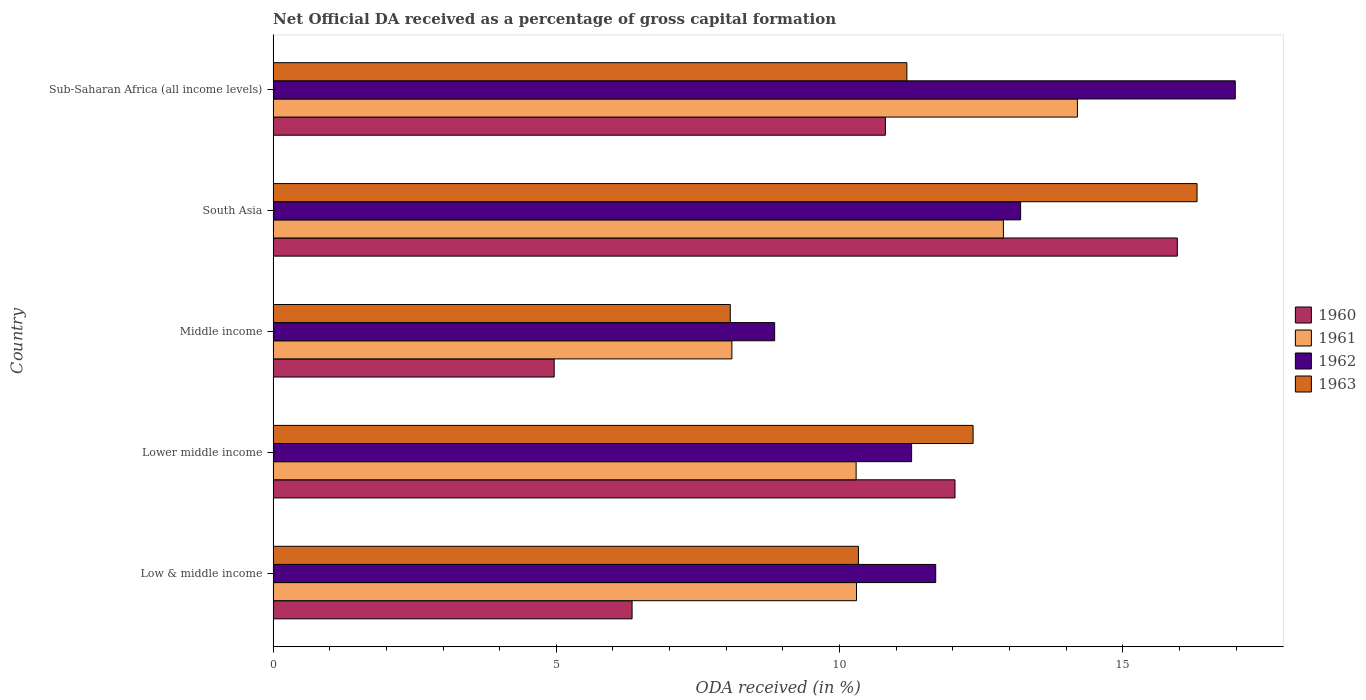How many different coloured bars are there?
Provide a short and direct response. 4. Are the number of bars per tick equal to the number of legend labels?
Give a very brief answer. Yes. How many bars are there on the 2nd tick from the top?
Make the answer very short. 4. What is the label of the 1st group of bars from the top?
Give a very brief answer. Sub-Saharan Africa (all income levels). What is the net ODA received in 1960 in Middle income?
Your answer should be very brief. 4.96. Across all countries, what is the maximum net ODA received in 1962?
Provide a succinct answer. 16.99. Across all countries, what is the minimum net ODA received in 1962?
Keep it short and to the point. 8.85. In which country was the net ODA received in 1963 maximum?
Give a very brief answer. South Asia. What is the total net ODA received in 1963 in the graph?
Provide a succinct answer. 58.26. What is the difference between the net ODA received in 1963 in Lower middle income and that in South Asia?
Offer a very short reply. -3.95. What is the difference between the net ODA received in 1961 in Middle income and the net ODA received in 1960 in Low & middle income?
Provide a short and direct response. 1.76. What is the average net ODA received in 1960 per country?
Offer a terse response. 10.02. What is the difference between the net ODA received in 1962 and net ODA received in 1960 in Low & middle income?
Provide a succinct answer. 5.36. In how many countries, is the net ODA received in 1961 greater than 6 %?
Your answer should be very brief. 5. What is the ratio of the net ODA received in 1962 in Low & middle income to that in Sub-Saharan Africa (all income levels)?
Provide a short and direct response. 0.69. What is the difference between the highest and the second highest net ODA received in 1960?
Your answer should be very brief. 3.93. What is the difference between the highest and the lowest net ODA received in 1960?
Keep it short and to the point. 11. In how many countries, is the net ODA received in 1962 greater than the average net ODA received in 1962 taken over all countries?
Your response must be concise. 2. Is the sum of the net ODA received in 1960 in Low & middle income and South Asia greater than the maximum net ODA received in 1962 across all countries?
Your response must be concise. Yes. Is it the case that in every country, the sum of the net ODA received in 1961 and net ODA received in 1963 is greater than the sum of net ODA received in 1960 and net ODA received in 1962?
Give a very brief answer. No. What does the 3rd bar from the top in Lower middle income represents?
Your answer should be compact. 1961. What does the 4th bar from the bottom in Lower middle income represents?
Offer a very short reply. 1963. How many bars are there?
Ensure brevity in your answer.  20. How many countries are there in the graph?
Offer a terse response. 5. Does the graph contain grids?
Your answer should be compact. No. How many legend labels are there?
Your answer should be very brief. 4. How are the legend labels stacked?
Your answer should be very brief. Vertical. What is the title of the graph?
Provide a short and direct response. Net Official DA received as a percentage of gross capital formation. Does "1975" appear as one of the legend labels in the graph?
Give a very brief answer. No. What is the label or title of the X-axis?
Your answer should be compact. ODA received (in %). What is the label or title of the Y-axis?
Your response must be concise. Country. What is the ODA received (in %) in 1960 in Low & middle income?
Provide a short and direct response. 6.34. What is the ODA received (in %) of 1961 in Low & middle income?
Make the answer very short. 10.3. What is the ODA received (in %) in 1962 in Low & middle income?
Keep it short and to the point. 11.7. What is the ODA received (in %) of 1963 in Low & middle income?
Make the answer very short. 10.33. What is the ODA received (in %) of 1960 in Lower middle income?
Your answer should be compact. 12.04. What is the ODA received (in %) in 1961 in Lower middle income?
Give a very brief answer. 10.29. What is the ODA received (in %) of 1962 in Lower middle income?
Keep it short and to the point. 11.27. What is the ODA received (in %) of 1963 in Lower middle income?
Your answer should be compact. 12.36. What is the ODA received (in %) in 1960 in Middle income?
Provide a succinct answer. 4.96. What is the ODA received (in %) in 1961 in Middle income?
Your response must be concise. 8.1. What is the ODA received (in %) in 1962 in Middle income?
Your answer should be very brief. 8.85. What is the ODA received (in %) in 1963 in Middle income?
Offer a very short reply. 8.07. What is the ODA received (in %) of 1960 in South Asia?
Make the answer very short. 15.96. What is the ODA received (in %) in 1961 in South Asia?
Provide a succinct answer. 12.89. What is the ODA received (in %) of 1962 in South Asia?
Provide a succinct answer. 13.2. What is the ODA received (in %) of 1963 in South Asia?
Offer a terse response. 16.31. What is the ODA received (in %) in 1960 in Sub-Saharan Africa (all income levels)?
Keep it short and to the point. 10.81. What is the ODA received (in %) in 1961 in Sub-Saharan Africa (all income levels)?
Give a very brief answer. 14.2. What is the ODA received (in %) of 1962 in Sub-Saharan Africa (all income levels)?
Offer a terse response. 16.99. What is the ODA received (in %) in 1963 in Sub-Saharan Africa (all income levels)?
Your answer should be compact. 11.19. Across all countries, what is the maximum ODA received (in %) in 1960?
Your answer should be very brief. 15.96. Across all countries, what is the maximum ODA received (in %) in 1961?
Give a very brief answer. 14.2. Across all countries, what is the maximum ODA received (in %) in 1962?
Offer a terse response. 16.99. Across all countries, what is the maximum ODA received (in %) of 1963?
Ensure brevity in your answer.  16.31. Across all countries, what is the minimum ODA received (in %) in 1960?
Keep it short and to the point. 4.96. Across all countries, what is the minimum ODA received (in %) in 1961?
Keep it short and to the point. 8.1. Across all countries, what is the minimum ODA received (in %) in 1962?
Provide a short and direct response. 8.85. Across all countries, what is the minimum ODA received (in %) of 1963?
Offer a very short reply. 8.07. What is the total ODA received (in %) in 1960 in the graph?
Keep it short and to the point. 50.11. What is the total ODA received (in %) in 1961 in the graph?
Keep it short and to the point. 55.78. What is the total ODA received (in %) in 1962 in the graph?
Keep it short and to the point. 62.01. What is the total ODA received (in %) in 1963 in the graph?
Your answer should be very brief. 58.26. What is the difference between the ODA received (in %) in 1960 in Low & middle income and that in Lower middle income?
Offer a terse response. -5.7. What is the difference between the ODA received (in %) in 1961 in Low & middle income and that in Lower middle income?
Make the answer very short. 0.01. What is the difference between the ODA received (in %) of 1962 in Low & middle income and that in Lower middle income?
Ensure brevity in your answer.  0.43. What is the difference between the ODA received (in %) in 1963 in Low & middle income and that in Lower middle income?
Keep it short and to the point. -2.02. What is the difference between the ODA received (in %) in 1960 in Low & middle income and that in Middle income?
Give a very brief answer. 1.38. What is the difference between the ODA received (in %) of 1961 in Low & middle income and that in Middle income?
Offer a very short reply. 2.2. What is the difference between the ODA received (in %) in 1962 in Low & middle income and that in Middle income?
Ensure brevity in your answer.  2.84. What is the difference between the ODA received (in %) of 1963 in Low & middle income and that in Middle income?
Provide a short and direct response. 2.26. What is the difference between the ODA received (in %) in 1960 in Low & middle income and that in South Asia?
Provide a short and direct response. -9.63. What is the difference between the ODA received (in %) in 1961 in Low & middle income and that in South Asia?
Ensure brevity in your answer.  -2.59. What is the difference between the ODA received (in %) of 1962 in Low & middle income and that in South Asia?
Provide a succinct answer. -1.5. What is the difference between the ODA received (in %) in 1963 in Low & middle income and that in South Asia?
Provide a short and direct response. -5.98. What is the difference between the ODA received (in %) of 1960 in Low & middle income and that in Sub-Saharan Africa (all income levels)?
Give a very brief answer. -4.47. What is the difference between the ODA received (in %) in 1961 in Low & middle income and that in Sub-Saharan Africa (all income levels)?
Give a very brief answer. -3.9. What is the difference between the ODA received (in %) of 1962 in Low & middle income and that in Sub-Saharan Africa (all income levels)?
Offer a terse response. -5.29. What is the difference between the ODA received (in %) in 1963 in Low & middle income and that in Sub-Saharan Africa (all income levels)?
Provide a succinct answer. -0.85. What is the difference between the ODA received (in %) in 1960 in Lower middle income and that in Middle income?
Your response must be concise. 7.08. What is the difference between the ODA received (in %) in 1961 in Lower middle income and that in Middle income?
Keep it short and to the point. 2.19. What is the difference between the ODA received (in %) of 1962 in Lower middle income and that in Middle income?
Provide a short and direct response. 2.42. What is the difference between the ODA received (in %) of 1963 in Lower middle income and that in Middle income?
Provide a short and direct response. 4.29. What is the difference between the ODA received (in %) of 1960 in Lower middle income and that in South Asia?
Offer a terse response. -3.93. What is the difference between the ODA received (in %) in 1961 in Lower middle income and that in South Asia?
Provide a succinct answer. -2.6. What is the difference between the ODA received (in %) in 1962 in Lower middle income and that in South Asia?
Make the answer very short. -1.92. What is the difference between the ODA received (in %) of 1963 in Lower middle income and that in South Asia?
Offer a very short reply. -3.95. What is the difference between the ODA received (in %) in 1960 in Lower middle income and that in Sub-Saharan Africa (all income levels)?
Your answer should be very brief. 1.23. What is the difference between the ODA received (in %) of 1961 in Lower middle income and that in Sub-Saharan Africa (all income levels)?
Offer a terse response. -3.91. What is the difference between the ODA received (in %) in 1962 in Lower middle income and that in Sub-Saharan Africa (all income levels)?
Offer a terse response. -5.71. What is the difference between the ODA received (in %) of 1963 in Lower middle income and that in Sub-Saharan Africa (all income levels)?
Offer a very short reply. 1.17. What is the difference between the ODA received (in %) of 1960 in Middle income and that in South Asia?
Provide a short and direct response. -11. What is the difference between the ODA received (in %) in 1961 in Middle income and that in South Asia?
Give a very brief answer. -4.79. What is the difference between the ODA received (in %) of 1962 in Middle income and that in South Asia?
Ensure brevity in your answer.  -4.34. What is the difference between the ODA received (in %) in 1963 in Middle income and that in South Asia?
Offer a terse response. -8.24. What is the difference between the ODA received (in %) of 1960 in Middle income and that in Sub-Saharan Africa (all income levels)?
Your answer should be very brief. -5.85. What is the difference between the ODA received (in %) of 1961 in Middle income and that in Sub-Saharan Africa (all income levels)?
Offer a terse response. -6.1. What is the difference between the ODA received (in %) of 1962 in Middle income and that in Sub-Saharan Africa (all income levels)?
Offer a terse response. -8.13. What is the difference between the ODA received (in %) of 1963 in Middle income and that in Sub-Saharan Africa (all income levels)?
Ensure brevity in your answer.  -3.12. What is the difference between the ODA received (in %) of 1960 in South Asia and that in Sub-Saharan Africa (all income levels)?
Your response must be concise. 5.15. What is the difference between the ODA received (in %) of 1961 in South Asia and that in Sub-Saharan Africa (all income levels)?
Keep it short and to the point. -1.31. What is the difference between the ODA received (in %) of 1962 in South Asia and that in Sub-Saharan Africa (all income levels)?
Provide a succinct answer. -3.79. What is the difference between the ODA received (in %) in 1963 in South Asia and that in Sub-Saharan Africa (all income levels)?
Your answer should be compact. 5.12. What is the difference between the ODA received (in %) of 1960 in Low & middle income and the ODA received (in %) of 1961 in Lower middle income?
Provide a short and direct response. -3.96. What is the difference between the ODA received (in %) in 1960 in Low & middle income and the ODA received (in %) in 1962 in Lower middle income?
Offer a very short reply. -4.93. What is the difference between the ODA received (in %) of 1960 in Low & middle income and the ODA received (in %) of 1963 in Lower middle income?
Offer a terse response. -6.02. What is the difference between the ODA received (in %) of 1961 in Low & middle income and the ODA received (in %) of 1962 in Lower middle income?
Your response must be concise. -0.97. What is the difference between the ODA received (in %) of 1961 in Low & middle income and the ODA received (in %) of 1963 in Lower middle income?
Your answer should be very brief. -2.06. What is the difference between the ODA received (in %) of 1962 in Low & middle income and the ODA received (in %) of 1963 in Lower middle income?
Make the answer very short. -0.66. What is the difference between the ODA received (in %) of 1960 in Low & middle income and the ODA received (in %) of 1961 in Middle income?
Keep it short and to the point. -1.76. What is the difference between the ODA received (in %) of 1960 in Low & middle income and the ODA received (in %) of 1962 in Middle income?
Provide a succinct answer. -2.52. What is the difference between the ODA received (in %) in 1960 in Low & middle income and the ODA received (in %) in 1963 in Middle income?
Offer a very short reply. -1.73. What is the difference between the ODA received (in %) of 1961 in Low & middle income and the ODA received (in %) of 1962 in Middle income?
Offer a very short reply. 1.44. What is the difference between the ODA received (in %) of 1961 in Low & middle income and the ODA received (in %) of 1963 in Middle income?
Offer a very short reply. 2.23. What is the difference between the ODA received (in %) of 1962 in Low & middle income and the ODA received (in %) of 1963 in Middle income?
Your answer should be compact. 3.63. What is the difference between the ODA received (in %) of 1960 in Low & middle income and the ODA received (in %) of 1961 in South Asia?
Offer a terse response. -6.56. What is the difference between the ODA received (in %) in 1960 in Low & middle income and the ODA received (in %) in 1962 in South Asia?
Give a very brief answer. -6.86. What is the difference between the ODA received (in %) of 1960 in Low & middle income and the ODA received (in %) of 1963 in South Asia?
Keep it short and to the point. -9.97. What is the difference between the ODA received (in %) in 1961 in Low & middle income and the ODA received (in %) in 1962 in South Asia?
Give a very brief answer. -2.9. What is the difference between the ODA received (in %) of 1961 in Low & middle income and the ODA received (in %) of 1963 in South Asia?
Make the answer very short. -6.01. What is the difference between the ODA received (in %) of 1962 in Low & middle income and the ODA received (in %) of 1963 in South Asia?
Ensure brevity in your answer.  -4.61. What is the difference between the ODA received (in %) in 1960 in Low & middle income and the ODA received (in %) in 1961 in Sub-Saharan Africa (all income levels)?
Make the answer very short. -7.86. What is the difference between the ODA received (in %) of 1960 in Low & middle income and the ODA received (in %) of 1962 in Sub-Saharan Africa (all income levels)?
Provide a succinct answer. -10.65. What is the difference between the ODA received (in %) of 1960 in Low & middle income and the ODA received (in %) of 1963 in Sub-Saharan Africa (all income levels)?
Provide a succinct answer. -4.85. What is the difference between the ODA received (in %) of 1961 in Low & middle income and the ODA received (in %) of 1962 in Sub-Saharan Africa (all income levels)?
Your response must be concise. -6.69. What is the difference between the ODA received (in %) in 1961 in Low & middle income and the ODA received (in %) in 1963 in Sub-Saharan Africa (all income levels)?
Keep it short and to the point. -0.89. What is the difference between the ODA received (in %) in 1962 in Low & middle income and the ODA received (in %) in 1963 in Sub-Saharan Africa (all income levels)?
Offer a very short reply. 0.51. What is the difference between the ODA received (in %) of 1960 in Lower middle income and the ODA received (in %) of 1961 in Middle income?
Provide a short and direct response. 3.94. What is the difference between the ODA received (in %) of 1960 in Lower middle income and the ODA received (in %) of 1962 in Middle income?
Offer a very short reply. 3.18. What is the difference between the ODA received (in %) of 1960 in Lower middle income and the ODA received (in %) of 1963 in Middle income?
Offer a terse response. 3.97. What is the difference between the ODA received (in %) of 1961 in Lower middle income and the ODA received (in %) of 1962 in Middle income?
Offer a very short reply. 1.44. What is the difference between the ODA received (in %) of 1961 in Lower middle income and the ODA received (in %) of 1963 in Middle income?
Keep it short and to the point. 2.22. What is the difference between the ODA received (in %) in 1962 in Lower middle income and the ODA received (in %) in 1963 in Middle income?
Give a very brief answer. 3.2. What is the difference between the ODA received (in %) in 1960 in Lower middle income and the ODA received (in %) in 1961 in South Asia?
Provide a short and direct response. -0.85. What is the difference between the ODA received (in %) of 1960 in Lower middle income and the ODA received (in %) of 1962 in South Asia?
Provide a short and direct response. -1.16. What is the difference between the ODA received (in %) in 1960 in Lower middle income and the ODA received (in %) in 1963 in South Asia?
Ensure brevity in your answer.  -4.27. What is the difference between the ODA received (in %) in 1961 in Lower middle income and the ODA received (in %) in 1962 in South Asia?
Provide a short and direct response. -2.9. What is the difference between the ODA received (in %) of 1961 in Lower middle income and the ODA received (in %) of 1963 in South Asia?
Offer a terse response. -6.02. What is the difference between the ODA received (in %) in 1962 in Lower middle income and the ODA received (in %) in 1963 in South Asia?
Give a very brief answer. -5.04. What is the difference between the ODA received (in %) in 1960 in Lower middle income and the ODA received (in %) in 1961 in Sub-Saharan Africa (all income levels)?
Provide a short and direct response. -2.16. What is the difference between the ODA received (in %) of 1960 in Lower middle income and the ODA received (in %) of 1962 in Sub-Saharan Africa (all income levels)?
Your response must be concise. -4.95. What is the difference between the ODA received (in %) in 1960 in Lower middle income and the ODA received (in %) in 1963 in Sub-Saharan Africa (all income levels)?
Make the answer very short. 0.85. What is the difference between the ODA received (in %) in 1961 in Lower middle income and the ODA received (in %) in 1962 in Sub-Saharan Africa (all income levels)?
Offer a very short reply. -6.69. What is the difference between the ODA received (in %) of 1961 in Lower middle income and the ODA received (in %) of 1963 in Sub-Saharan Africa (all income levels)?
Provide a short and direct response. -0.9. What is the difference between the ODA received (in %) of 1962 in Lower middle income and the ODA received (in %) of 1963 in Sub-Saharan Africa (all income levels)?
Provide a succinct answer. 0.08. What is the difference between the ODA received (in %) in 1960 in Middle income and the ODA received (in %) in 1961 in South Asia?
Ensure brevity in your answer.  -7.93. What is the difference between the ODA received (in %) of 1960 in Middle income and the ODA received (in %) of 1962 in South Asia?
Ensure brevity in your answer.  -8.23. What is the difference between the ODA received (in %) of 1960 in Middle income and the ODA received (in %) of 1963 in South Asia?
Your response must be concise. -11.35. What is the difference between the ODA received (in %) in 1961 in Middle income and the ODA received (in %) in 1962 in South Asia?
Provide a short and direct response. -5.1. What is the difference between the ODA received (in %) of 1961 in Middle income and the ODA received (in %) of 1963 in South Asia?
Provide a short and direct response. -8.21. What is the difference between the ODA received (in %) of 1962 in Middle income and the ODA received (in %) of 1963 in South Asia?
Give a very brief answer. -7.46. What is the difference between the ODA received (in %) of 1960 in Middle income and the ODA received (in %) of 1961 in Sub-Saharan Africa (all income levels)?
Your answer should be compact. -9.24. What is the difference between the ODA received (in %) of 1960 in Middle income and the ODA received (in %) of 1962 in Sub-Saharan Africa (all income levels)?
Provide a short and direct response. -12.02. What is the difference between the ODA received (in %) in 1960 in Middle income and the ODA received (in %) in 1963 in Sub-Saharan Africa (all income levels)?
Provide a succinct answer. -6.23. What is the difference between the ODA received (in %) in 1961 in Middle income and the ODA received (in %) in 1962 in Sub-Saharan Africa (all income levels)?
Your answer should be very brief. -8.89. What is the difference between the ODA received (in %) of 1961 in Middle income and the ODA received (in %) of 1963 in Sub-Saharan Africa (all income levels)?
Your answer should be very brief. -3.09. What is the difference between the ODA received (in %) in 1962 in Middle income and the ODA received (in %) in 1963 in Sub-Saharan Africa (all income levels)?
Offer a terse response. -2.33. What is the difference between the ODA received (in %) of 1960 in South Asia and the ODA received (in %) of 1961 in Sub-Saharan Africa (all income levels)?
Offer a terse response. 1.76. What is the difference between the ODA received (in %) of 1960 in South Asia and the ODA received (in %) of 1962 in Sub-Saharan Africa (all income levels)?
Make the answer very short. -1.02. What is the difference between the ODA received (in %) of 1960 in South Asia and the ODA received (in %) of 1963 in Sub-Saharan Africa (all income levels)?
Keep it short and to the point. 4.77. What is the difference between the ODA received (in %) of 1961 in South Asia and the ODA received (in %) of 1962 in Sub-Saharan Africa (all income levels)?
Offer a terse response. -4.09. What is the difference between the ODA received (in %) of 1961 in South Asia and the ODA received (in %) of 1963 in Sub-Saharan Africa (all income levels)?
Your answer should be compact. 1.7. What is the difference between the ODA received (in %) of 1962 in South Asia and the ODA received (in %) of 1963 in Sub-Saharan Africa (all income levels)?
Your response must be concise. 2.01. What is the average ODA received (in %) of 1960 per country?
Your response must be concise. 10.02. What is the average ODA received (in %) in 1961 per country?
Your answer should be compact. 11.16. What is the average ODA received (in %) of 1962 per country?
Provide a short and direct response. 12.4. What is the average ODA received (in %) of 1963 per country?
Provide a succinct answer. 11.65. What is the difference between the ODA received (in %) of 1960 and ODA received (in %) of 1961 in Low & middle income?
Your answer should be compact. -3.96. What is the difference between the ODA received (in %) in 1960 and ODA received (in %) in 1962 in Low & middle income?
Keep it short and to the point. -5.36. What is the difference between the ODA received (in %) in 1960 and ODA received (in %) in 1963 in Low & middle income?
Provide a short and direct response. -4. What is the difference between the ODA received (in %) in 1961 and ODA received (in %) in 1962 in Low & middle income?
Your response must be concise. -1.4. What is the difference between the ODA received (in %) of 1961 and ODA received (in %) of 1963 in Low & middle income?
Your response must be concise. -0.03. What is the difference between the ODA received (in %) in 1962 and ODA received (in %) in 1963 in Low & middle income?
Provide a succinct answer. 1.36. What is the difference between the ODA received (in %) of 1960 and ODA received (in %) of 1961 in Lower middle income?
Make the answer very short. 1.75. What is the difference between the ODA received (in %) in 1960 and ODA received (in %) in 1962 in Lower middle income?
Keep it short and to the point. 0.77. What is the difference between the ODA received (in %) of 1960 and ODA received (in %) of 1963 in Lower middle income?
Ensure brevity in your answer.  -0.32. What is the difference between the ODA received (in %) of 1961 and ODA received (in %) of 1962 in Lower middle income?
Give a very brief answer. -0.98. What is the difference between the ODA received (in %) of 1961 and ODA received (in %) of 1963 in Lower middle income?
Offer a terse response. -2.07. What is the difference between the ODA received (in %) of 1962 and ODA received (in %) of 1963 in Lower middle income?
Provide a succinct answer. -1.09. What is the difference between the ODA received (in %) in 1960 and ODA received (in %) in 1961 in Middle income?
Your answer should be very brief. -3.14. What is the difference between the ODA received (in %) in 1960 and ODA received (in %) in 1962 in Middle income?
Provide a succinct answer. -3.89. What is the difference between the ODA received (in %) in 1960 and ODA received (in %) in 1963 in Middle income?
Provide a short and direct response. -3.11. What is the difference between the ODA received (in %) of 1961 and ODA received (in %) of 1962 in Middle income?
Ensure brevity in your answer.  -0.75. What is the difference between the ODA received (in %) of 1961 and ODA received (in %) of 1963 in Middle income?
Give a very brief answer. 0.03. What is the difference between the ODA received (in %) of 1962 and ODA received (in %) of 1963 in Middle income?
Provide a short and direct response. 0.78. What is the difference between the ODA received (in %) in 1960 and ODA received (in %) in 1961 in South Asia?
Give a very brief answer. 3.07. What is the difference between the ODA received (in %) of 1960 and ODA received (in %) of 1962 in South Asia?
Provide a short and direct response. 2.77. What is the difference between the ODA received (in %) of 1960 and ODA received (in %) of 1963 in South Asia?
Provide a short and direct response. -0.35. What is the difference between the ODA received (in %) in 1961 and ODA received (in %) in 1962 in South Asia?
Ensure brevity in your answer.  -0.3. What is the difference between the ODA received (in %) in 1961 and ODA received (in %) in 1963 in South Asia?
Give a very brief answer. -3.42. What is the difference between the ODA received (in %) in 1962 and ODA received (in %) in 1963 in South Asia?
Offer a very short reply. -3.11. What is the difference between the ODA received (in %) of 1960 and ODA received (in %) of 1961 in Sub-Saharan Africa (all income levels)?
Provide a succinct answer. -3.39. What is the difference between the ODA received (in %) in 1960 and ODA received (in %) in 1962 in Sub-Saharan Africa (all income levels)?
Provide a short and direct response. -6.18. What is the difference between the ODA received (in %) of 1960 and ODA received (in %) of 1963 in Sub-Saharan Africa (all income levels)?
Your response must be concise. -0.38. What is the difference between the ODA received (in %) in 1961 and ODA received (in %) in 1962 in Sub-Saharan Africa (all income levels)?
Make the answer very short. -2.79. What is the difference between the ODA received (in %) of 1961 and ODA received (in %) of 1963 in Sub-Saharan Africa (all income levels)?
Provide a succinct answer. 3.01. What is the difference between the ODA received (in %) of 1962 and ODA received (in %) of 1963 in Sub-Saharan Africa (all income levels)?
Your response must be concise. 5.8. What is the ratio of the ODA received (in %) of 1960 in Low & middle income to that in Lower middle income?
Your answer should be compact. 0.53. What is the ratio of the ODA received (in %) in 1961 in Low & middle income to that in Lower middle income?
Your answer should be very brief. 1. What is the ratio of the ODA received (in %) of 1962 in Low & middle income to that in Lower middle income?
Your answer should be very brief. 1.04. What is the ratio of the ODA received (in %) in 1963 in Low & middle income to that in Lower middle income?
Provide a succinct answer. 0.84. What is the ratio of the ODA received (in %) in 1960 in Low & middle income to that in Middle income?
Ensure brevity in your answer.  1.28. What is the ratio of the ODA received (in %) in 1961 in Low & middle income to that in Middle income?
Your answer should be very brief. 1.27. What is the ratio of the ODA received (in %) in 1962 in Low & middle income to that in Middle income?
Your answer should be compact. 1.32. What is the ratio of the ODA received (in %) in 1963 in Low & middle income to that in Middle income?
Ensure brevity in your answer.  1.28. What is the ratio of the ODA received (in %) of 1960 in Low & middle income to that in South Asia?
Offer a very short reply. 0.4. What is the ratio of the ODA received (in %) of 1961 in Low & middle income to that in South Asia?
Give a very brief answer. 0.8. What is the ratio of the ODA received (in %) in 1962 in Low & middle income to that in South Asia?
Keep it short and to the point. 0.89. What is the ratio of the ODA received (in %) in 1963 in Low & middle income to that in South Asia?
Keep it short and to the point. 0.63. What is the ratio of the ODA received (in %) in 1960 in Low & middle income to that in Sub-Saharan Africa (all income levels)?
Ensure brevity in your answer.  0.59. What is the ratio of the ODA received (in %) of 1961 in Low & middle income to that in Sub-Saharan Africa (all income levels)?
Provide a succinct answer. 0.73. What is the ratio of the ODA received (in %) of 1962 in Low & middle income to that in Sub-Saharan Africa (all income levels)?
Your response must be concise. 0.69. What is the ratio of the ODA received (in %) of 1963 in Low & middle income to that in Sub-Saharan Africa (all income levels)?
Give a very brief answer. 0.92. What is the ratio of the ODA received (in %) in 1960 in Lower middle income to that in Middle income?
Provide a succinct answer. 2.43. What is the ratio of the ODA received (in %) in 1961 in Lower middle income to that in Middle income?
Your answer should be very brief. 1.27. What is the ratio of the ODA received (in %) of 1962 in Lower middle income to that in Middle income?
Ensure brevity in your answer.  1.27. What is the ratio of the ODA received (in %) of 1963 in Lower middle income to that in Middle income?
Offer a very short reply. 1.53. What is the ratio of the ODA received (in %) of 1960 in Lower middle income to that in South Asia?
Keep it short and to the point. 0.75. What is the ratio of the ODA received (in %) of 1961 in Lower middle income to that in South Asia?
Provide a succinct answer. 0.8. What is the ratio of the ODA received (in %) of 1962 in Lower middle income to that in South Asia?
Keep it short and to the point. 0.85. What is the ratio of the ODA received (in %) of 1963 in Lower middle income to that in South Asia?
Your response must be concise. 0.76. What is the ratio of the ODA received (in %) in 1960 in Lower middle income to that in Sub-Saharan Africa (all income levels)?
Provide a succinct answer. 1.11. What is the ratio of the ODA received (in %) in 1961 in Lower middle income to that in Sub-Saharan Africa (all income levels)?
Ensure brevity in your answer.  0.72. What is the ratio of the ODA received (in %) of 1962 in Lower middle income to that in Sub-Saharan Africa (all income levels)?
Make the answer very short. 0.66. What is the ratio of the ODA received (in %) of 1963 in Lower middle income to that in Sub-Saharan Africa (all income levels)?
Ensure brevity in your answer.  1.1. What is the ratio of the ODA received (in %) in 1960 in Middle income to that in South Asia?
Provide a succinct answer. 0.31. What is the ratio of the ODA received (in %) in 1961 in Middle income to that in South Asia?
Give a very brief answer. 0.63. What is the ratio of the ODA received (in %) of 1962 in Middle income to that in South Asia?
Provide a succinct answer. 0.67. What is the ratio of the ODA received (in %) in 1963 in Middle income to that in South Asia?
Make the answer very short. 0.49. What is the ratio of the ODA received (in %) in 1960 in Middle income to that in Sub-Saharan Africa (all income levels)?
Provide a short and direct response. 0.46. What is the ratio of the ODA received (in %) of 1961 in Middle income to that in Sub-Saharan Africa (all income levels)?
Your answer should be very brief. 0.57. What is the ratio of the ODA received (in %) of 1962 in Middle income to that in Sub-Saharan Africa (all income levels)?
Provide a short and direct response. 0.52. What is the ratio of the ODA received (in %) of 1963 in Middle income to that in Sub-Saharan Africa (all income levels)?
Give a very brief answer. 0.72. What is the ratio of the ODA received (in %) in 1960 in South Asia to that in Sub-Saharan Africa (all income levels)?
Keep it short and to the point. 1.48. What is the ratio of the ODA received (in %) of 1961 in South Asia to that in Sub-Saharan Africa (all income levels)?
Your answer should be compact. 0.91. What is the ratio of the ODA received (in %) in 1962 in South Asia to that in Sub-Saharan Africa (all income levels)?
Your answer should be compact. 0.78. What is the ratio of the ODA received (in %) of 1963 in South Asia to that in Sub-Saharan Africa (all income levels)?
Ensure brevity in your answer.  1.46. What is the difference between the highest and the second highest ODA received (in %) of 1960?
Offer a terse response. 3.93. What is the difference between the highest and the second highest ODA received (in %) of 1961?
Give a very brief answer. 1.31. What is the difference between the highest and the second highest ODA received (in %) in 1962?
Provide a short and direct response. 3.79. What is the difference between the highest and the second highest ODA received (in %) of 1963?
Your response must be concise. 3.95. What is the difference between the highest and the lowest ODA received (in %) of 1960?
Your answer should be compact. 11. What is the difference between the highest and the lowest ODA received (in %) of 1961?
Make the answer very short. 6.1. What is the difference between the highest and the lowest ODA received (in %) in 1962?
Ensure brevity in your answer.  8.13. What is the difference between the highest and the lowest ODA received (in %) of 1963?
Provide a succinct answer. 8.24. 